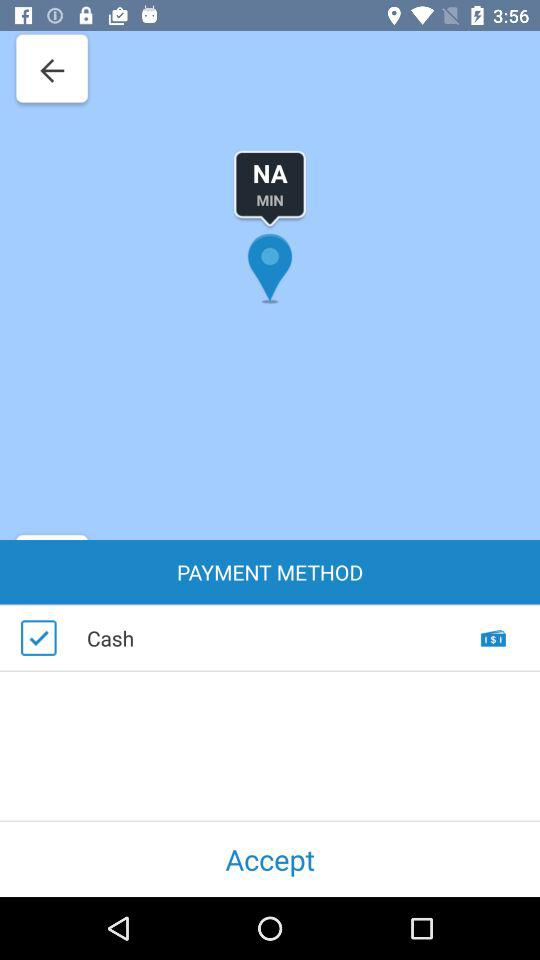What is the selected payment method? The selected payment method is "Cash". 